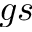Convert formula to latex. <formula><loc_0><loc_0><loc_500><loc_500>g s</formula> 